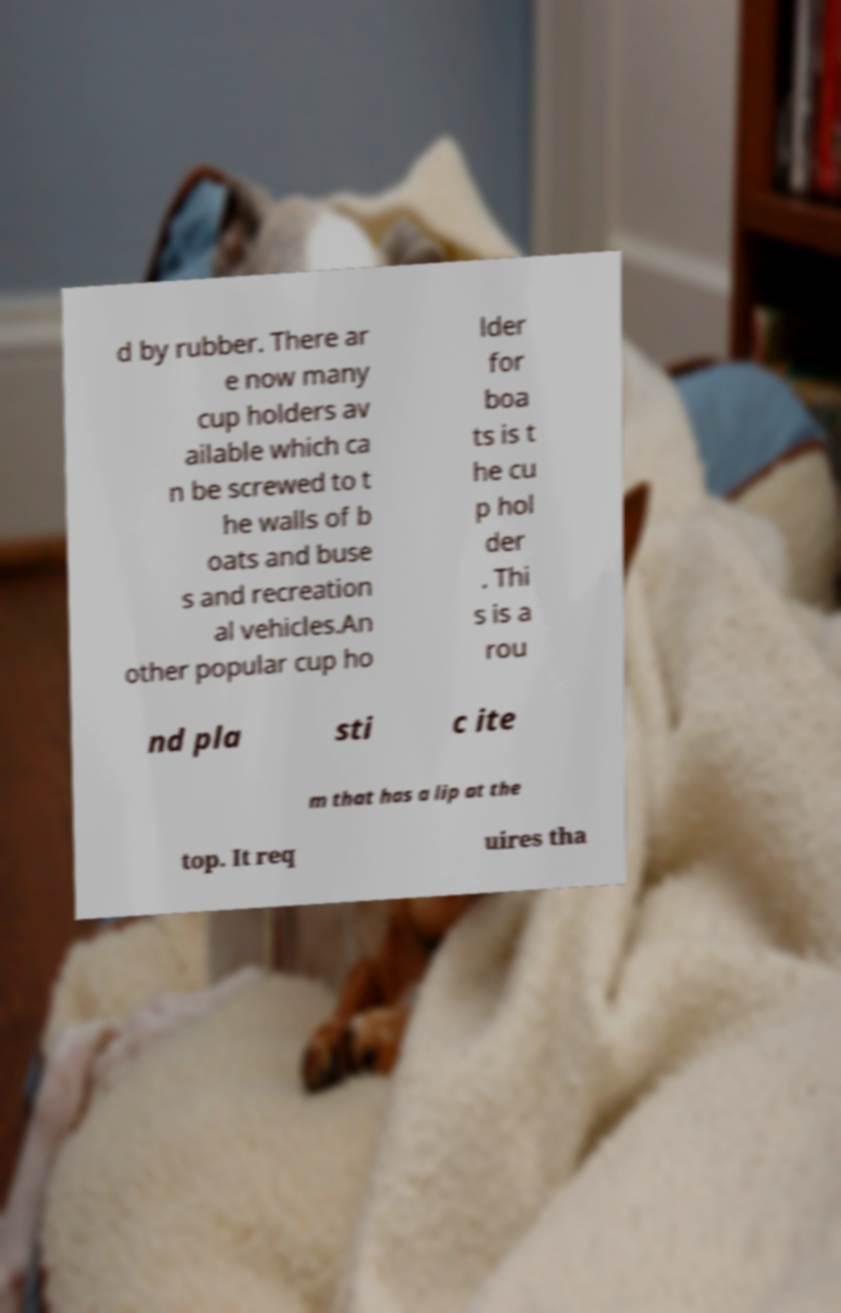Please identify and transcribe the text found in this image. d by rubber. There ar e now many cup holders av ailable which ca n be screwed to t he walls of b oats and buse s and recreation al vehicles.An other popular cup ho lder for boa ts is t he cu p hol der . Thi s is a rou nd pla sti c ite m that has a lip at the top. It req uires tha 